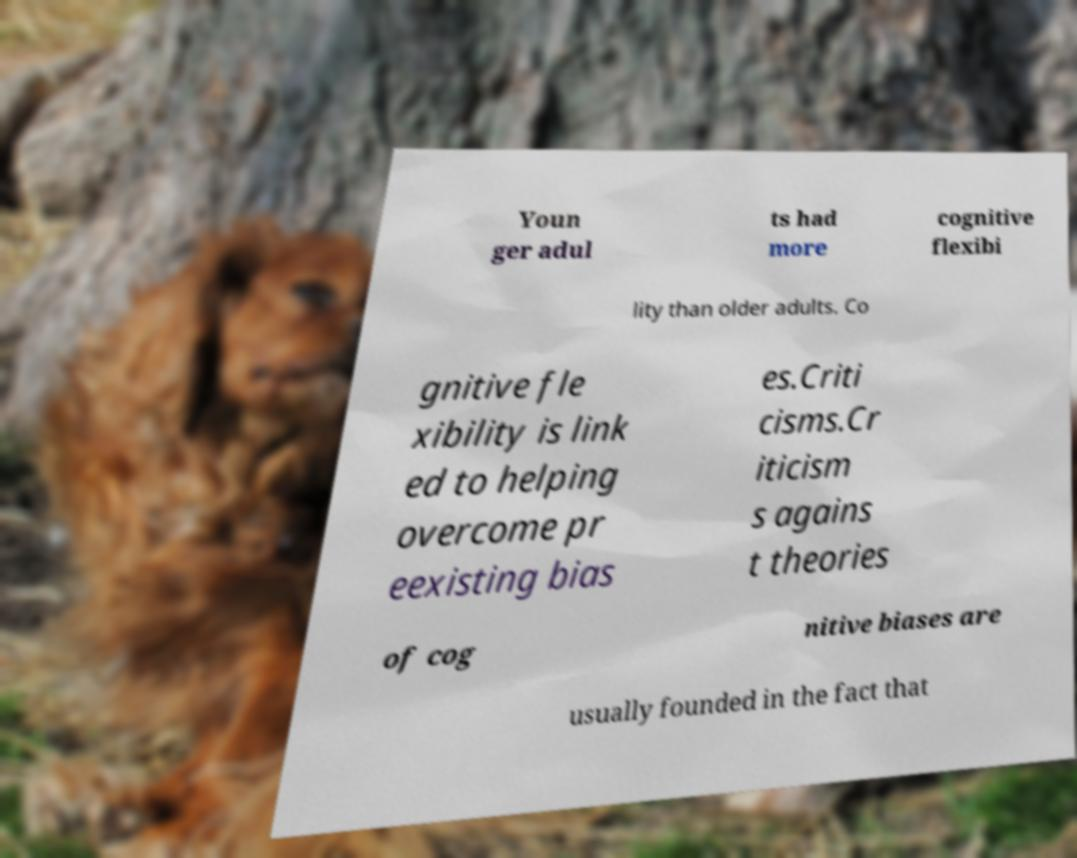Could you extract and type out the text from this image? Youn ger adul ts had more cognitive flexibi lity than older adults. Co gnitive fle xibility is link ed to helping overcome pr eexisting bias es.Criti cisms.Cr iticism s agains t theories of cog nitive biases are usually founded in the fact that 